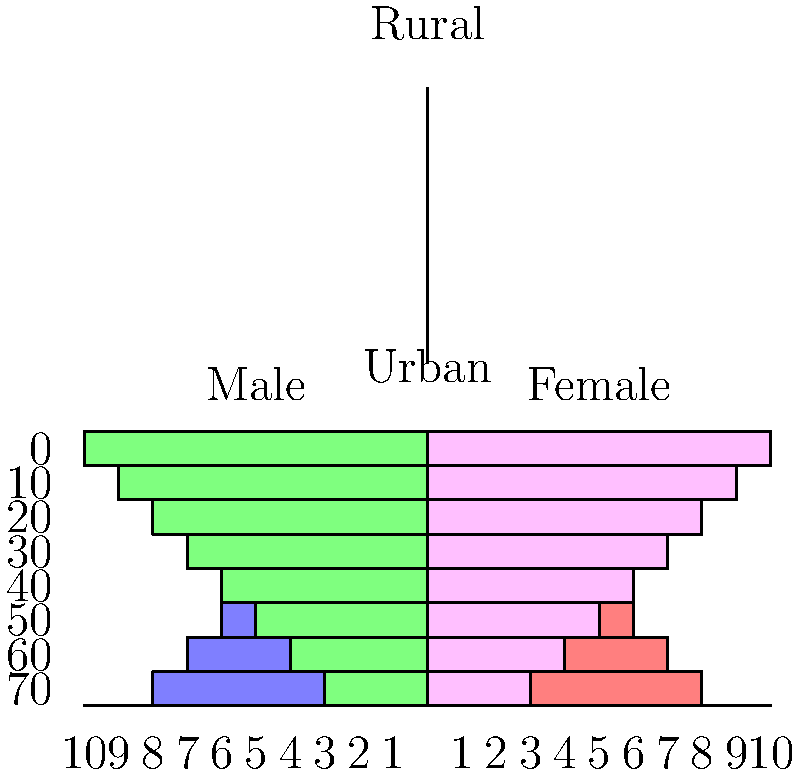As a politician advocating for targeted development policies, you're presented with population pyramids for urban and rural areas. What key demographic trend do these pyramids reveal, and how might you use this information to garner support for your infrastructure development projects? To answer this question, let's analyze the population pyramids step by step:

1. Urban population pyramid (top):
   - The pyramid has a relatively even distribution across age groups.
   - There's a slight bulge in the middle-age groups.
   - The top of the pyramid (older age groups) is narrower.

2. Rural population pyramid (bottom):
   - The pyramid has a wide base, indicating a larger younger population.
   - It narrows significantly towards the top, showing fewer older individuals.

3. Key demographic trend:
   - The rural areas have a much younger population compared to urban areas.
   - Urban areas have a more balanced age distribution, suggesting an aging population.

4. Implications for infrastructure development:
   - Rural areas: Need for schools, youth centers, and job creation initiatives.
   - Urban areas: Increasing demand for healthcare facilities and senior care services.

5. Using this information to garner support:
   - Emphasize the need for targeted investments based on demographic differences.
   - Argue for balanced development to address both rural youth needs and urban aging population requirements.
   - Propose projects that create jobs in rural areas to retain young population and support services for the aging urban population.

6. Political strategy:
   - Frame the infrastructure projects as essential for addressing demographic challenges.
   - Highlight how these investments will improve quality of life across all age groups and regions.
   - Emphasize the long-term economic benefits of adapting to these demographic shifts.
Answer: Rural areas have a younger population, while urban areas show an aging trend. This justifies targeted infrastructure investments to address specific needs in both regions. 